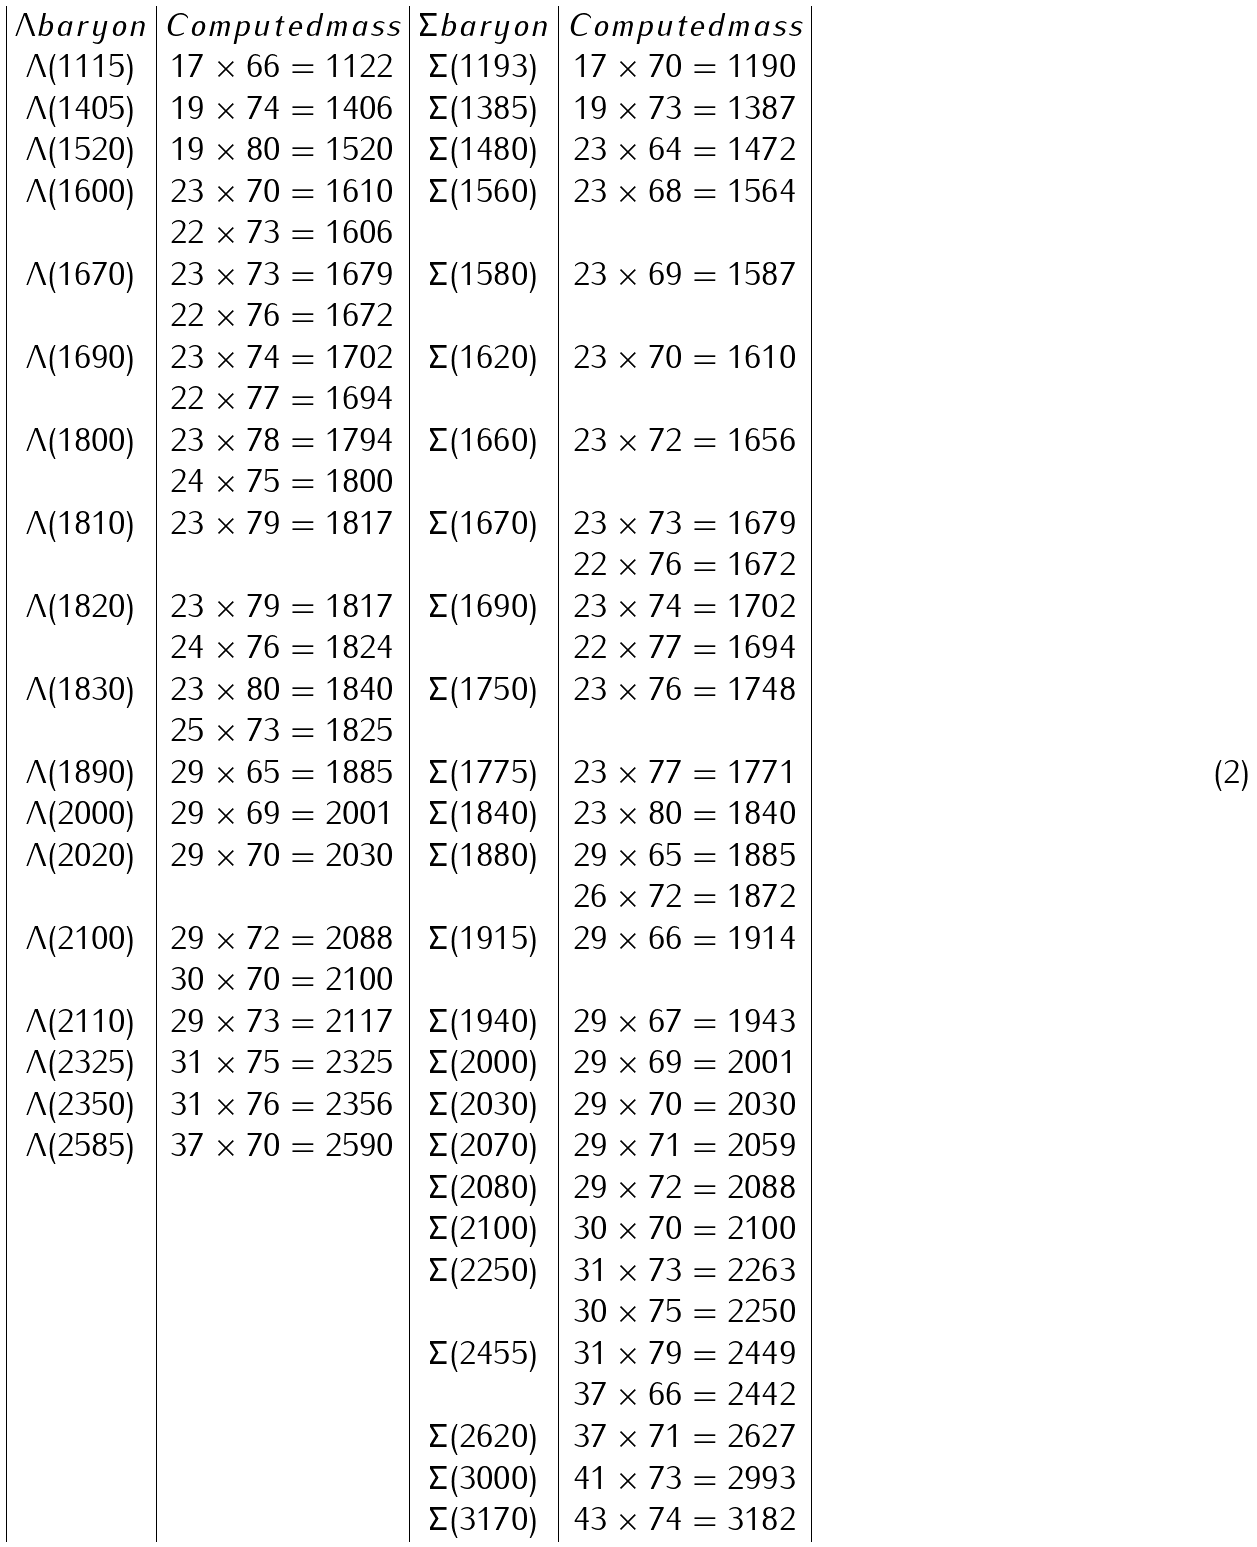<formula> <loc_0><loc_0><loc_500><loc_500>\begin{array} { | c | c | c | c | } \Lambda b a r y o n & C o m p u t e d m a s s & \Sigma b a r y o n & C o m p u t e d m a s s \\ \Lambda ( 1 1 1 5 ) & { 1 7 } \times 6 6 = 1 1 2 2 & \Sigma ( 1 1 9 3 ) & { 1 7 } \times 7 0 = 1 1 9 0 \\ \Lambda ( 1 4 0 5 ) & { 1 9 } \times 7 4 = 1 4 0 6 & \Sigma ( 1 3 8 5 ) & { 1 9 } \times 7 3 = 1 3 8 7 \\ \Lambda ( 1 5 2 0 ) & { 1 9 } \times 8 0 = 1 5 2 0 & \Sigma ( 1 4 8 0 ) & { 2 3 } \times 6 4 = 1 4 7 2 \\ \Lambda ( 1 6 0 0 ) & { 2 3 } \times 7 0 = 1 6 1 0 & \Sigma ( 1 5 6 0 ) & { 2 3 } \times 6 8 = 1 5 6 4 \\ & 2 2 \times 7 3 = 1 6 0 6 & & \\ \Lambda ( 1 6 7 0 ) & { 2 3 } \times 7 3 = 1 6 7 9 & \Sigma ( 1 5 8 0 ) & { 2 3 } \times 6 9 = 1 5 8 7 \\ & 2 2 \times 7 6 = 1 6 7 2 & & \\ \Lambda ( 1 6 9 0 ) & { 2 3 } \times 7 4 = 1 7 0 2 & \Sigma ( 1 6 2 0 ) & { 2 3 } \times 7 0 = 1 6 1 0 \\ & 2 2 \times 7 7 = 1 6 9 4 & & \\ \Lambda ( 1 8 0 0 ) & { 2 3 } \times 7 8 = 1 7 9 4 & \Sigma ( 1 6 6 0 ) & { 2 3 } \times 7 2 = 1 6 5 6 \\ & 2 4 \times 7 5 = 1 8 0 0 & & \\ \Lambda ( 1 8 1 0 ) & { 2 3 } \times 7 9 = 1 8 1 7 & \Sigma ( 1 6 7 0 ) & { 2 3 } \times 7 3 = 1 6 7 9 \\ & & & 2 2 \times 7 6 = 1 6 7 2 \\ \Lambda ( 1 8 2 0 ) & { 2 3 } \times 7 9 = 1 8 1 7 & \Sigma ( 1 6 9 0 ) & { 2 3 } \times 7 4 = 1 7 0 2 \\ & 2 4 \times 7 6 = 1 8 2 4 & & 2 2 \times 7 7 = 1 6 9 4 \\ \Lambda ( 1 8 3 0 ) & { 2 3 } \times 8 0 = 1 8 4 0 & \Sigma ( 1 7 5 0 ) & { 2 3 } \times 7 6 = 1 7 4 8 \\ & 2 5 \times 7 3 = 1 8 2 5 & & \\ \Lambda ( 1 8 9 0 ) & { 2 9 } \times 6 5 = 1 8 8 5 & \Sigma ( 1 7 7 5 ) & { 2 3 } \times 7 7 = 1 7 7 1 \\ \Lambda ( 2 0 0 0 ) & { 2 9 } \times 6 9 = 2 0 0 1 & \Sigma ( 1 8 4 0 ) & { 2 3 } \times 8 0 = 1 8 4 0 \\ \Lambda ( 2 0 2 0 ) & { 2 9 } \times 7 0 = 2 0 3 0 & \Sigma ( 1 8 8 0 ) & { 2 9 } \times 6 5 = 1 8 8 5 \\ & & & 2 6 \times 7 2 = 1 8 7 2 \\ \Lambda ( 2 1 0 0 ) & { 2 9 } \times 7 2 = 2 0 8 8 & \Sigma ( 1 9 1 5 ) & { 2 9 } \times 6 6 = 1 9 1 4 \\ & 3 0 \times 7 0 = 2 1 0 0 & & \\ \Lambda ( 2 1 1 0 ) & { 2 9 } \times 7 3 = 2 1 1 7 & \Sigma ( 1 9 4 0 ) & { 2 9 } \times 6 7 = 1 9 4 3 \\ \Lambda ( 2 3 2 5 ) & { 3 1 } \times 7 5 = 2 3 2 5 & \Sigma ( 2 0 0 0 ) & { 2 9 } \times 6 9 = 2 0 0 1 \\ \Lambda ( 2 3 5 0 ) & { 3 1 } \times 7 6 = 2 3 5 6 & \Sigma ( 2 0 3 0 ) & { 2 9 } \times 7 0 = 2 0 3 0 \\ \Lambda ( 2 5 8 5 ) & { 3 7 } \times 7 0 = 2 5 9 0 & \Sigma ( 2 0 7 0 ) & { 2 9 } \times 7 1 = 2 0 5 9 \\ & & \Sigma ( 2 0 8 0 ) & { 2 9 } \times 7 2 = 2 0 8 8 \\ & & \Sigma ( 2 1 0 0 ) & { 3 0 } \times 7 0 = 2 1 0 0 \\ & & \Sigma ( 2 2 5 0 ) & { 3 1 } \times 7 3 = 2 2 6 3 \\ & & & 3 0 \times 7 5 = 2 2 5 0 \\ & & \Sigma ( 2 4 5 5 ) & { 3 1 } \times 7 9 = 2 4 4 9 \\ & & & { 3 7 } \times 6 6 = 2 4 4 2 \\ & & \Sigma ( 2 6 2 0 ) & { 3 7 } \times 7 1 = 2 6 2 7 \\ & & \Sigma ( 3 0 0 0 ) & { 4 1 } \times 7 3 = 2 9 9 3 \\ & & \Sigma ( 3 1 7 0 ) & { 4 3 } \times 7 4 = 3 1 8 2 \\ \end{array}</formula> 